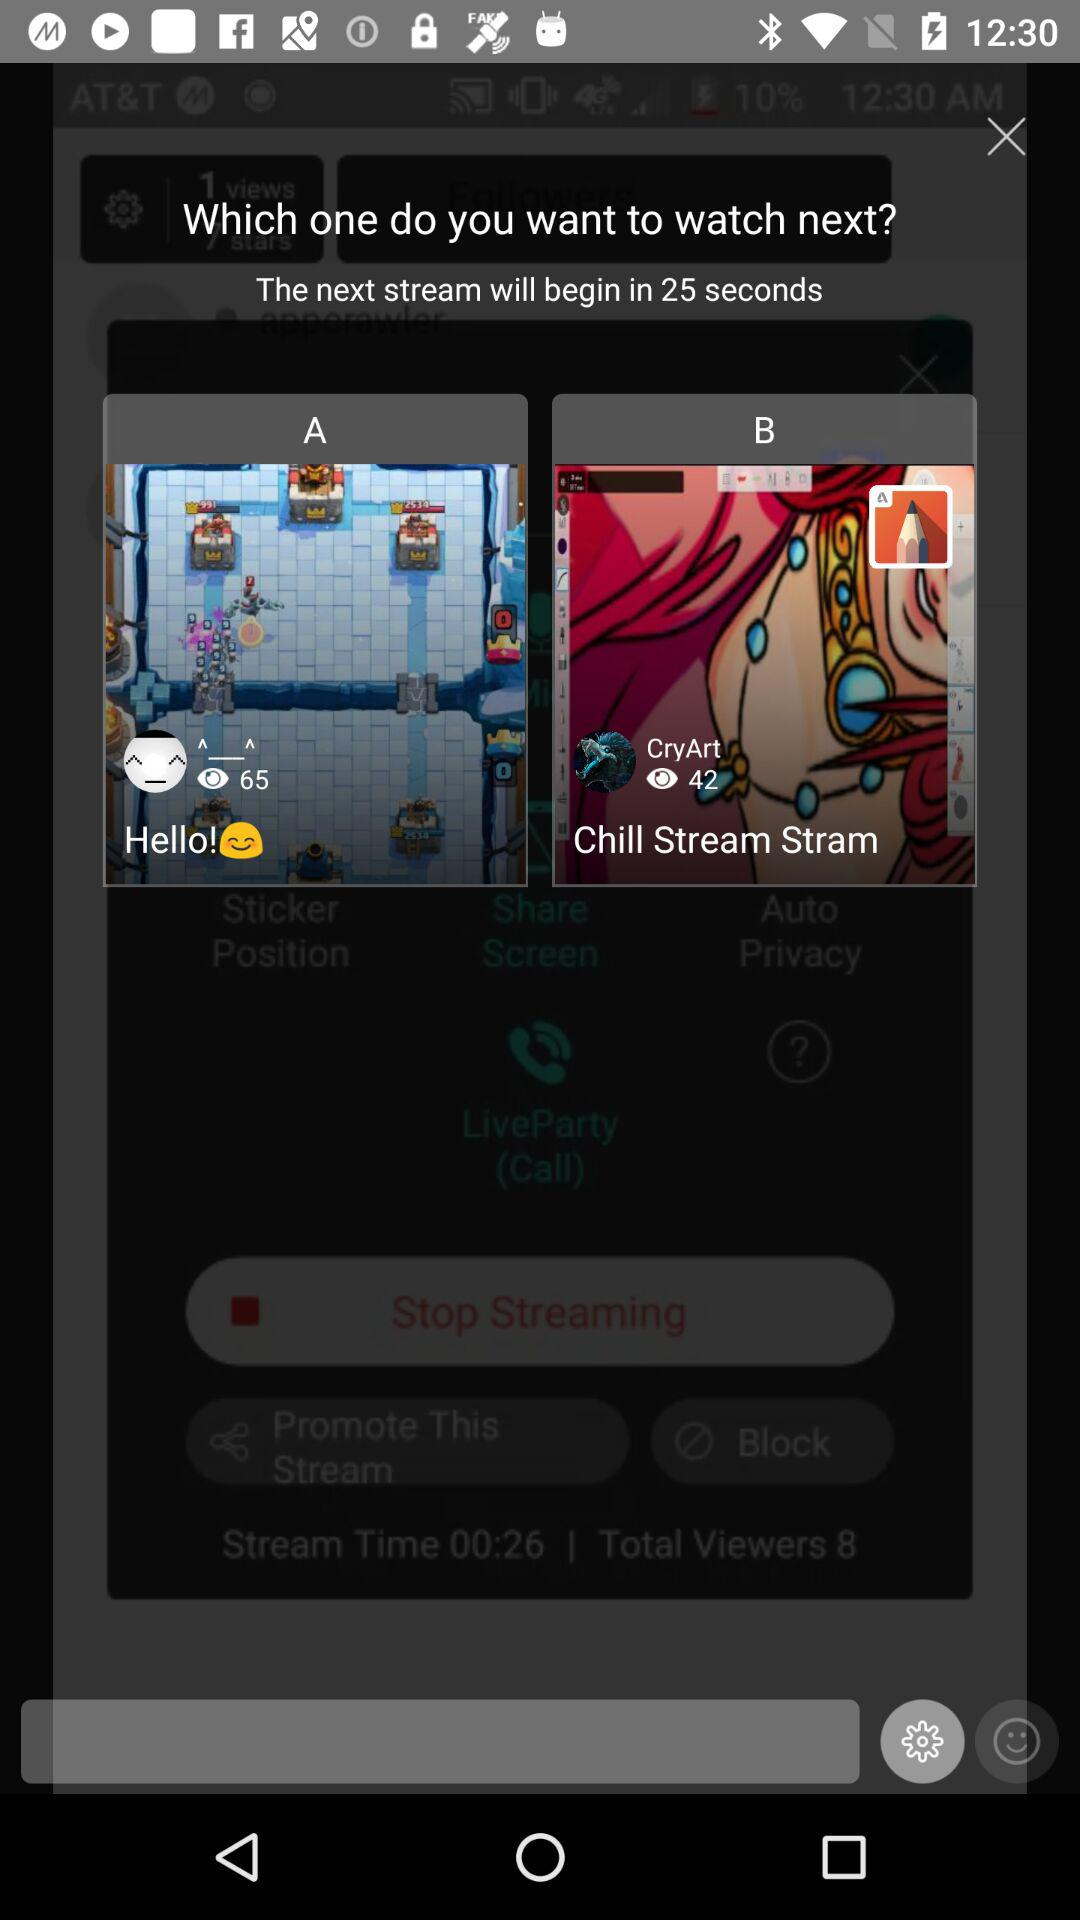Is option "A" selected?
When the provided information is insufficient, respond with <no answer>. <no answer> 